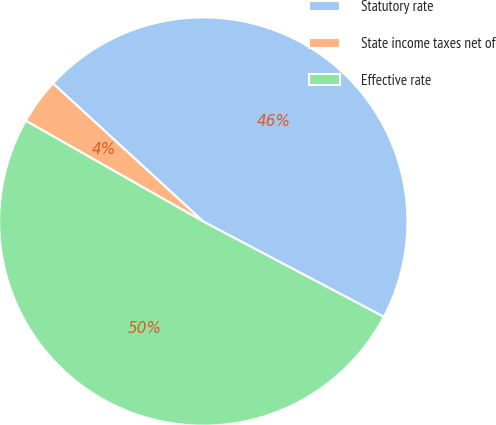Convert chart to OTSL. <chart><loc_0><loc_0><loc_500><loc_500><pie_chart><fcel>Statutory rate<fcel>State income taxes net of<fcel>Effective rate<nl><fcel>45.9%<fcel>3.61%<fcel>50.49%<nl></chart> 